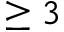<formula> <loc_0><loc_0><loc_500><loc_500>\geq 3</formula> 